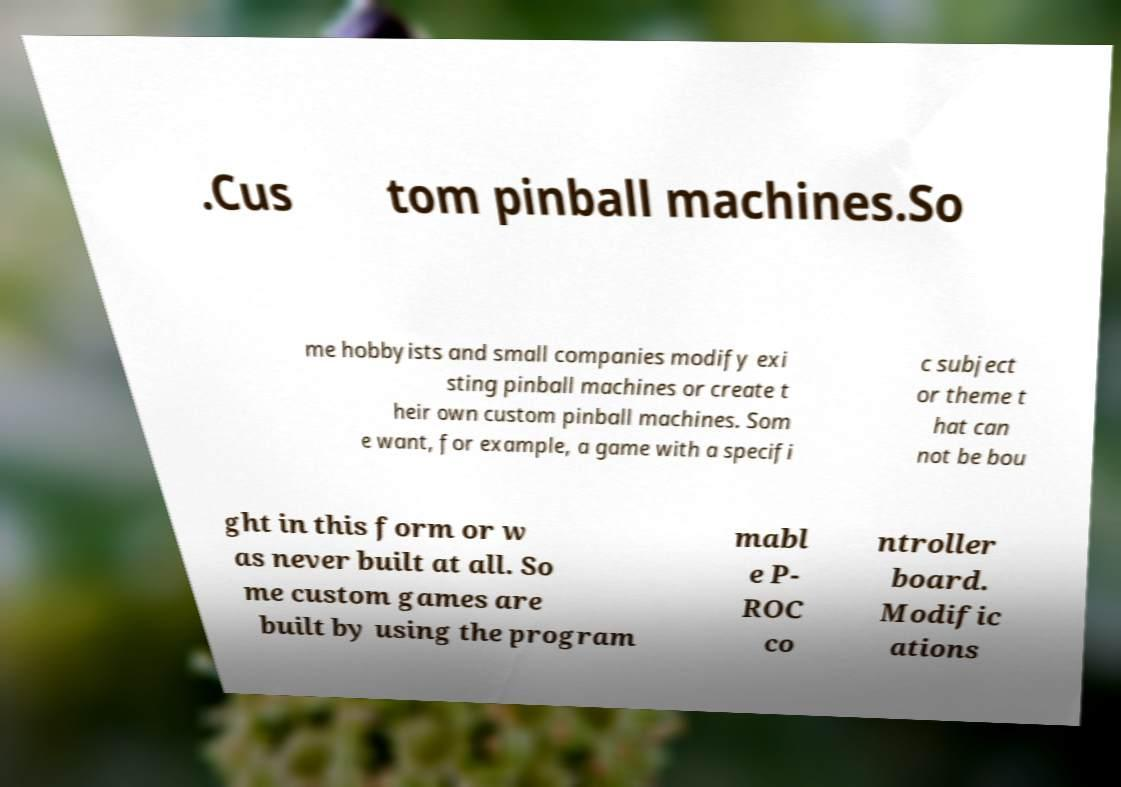Can you read and provide the text displayed in the image?This photo seems to have some interesting text. Can you extract and type it out for me? .Cus tom pinball machines.So me hobbyists and small companies modify exi sting pinball machines or create t heir own custom pinball machines. Som e want, for example, a game with a specifi c subject or theme t hat can not be bou ght in this form or w as never built at all. So me custom games are built by using the program mabl e P- ROC co ntroller board. Modific ations 